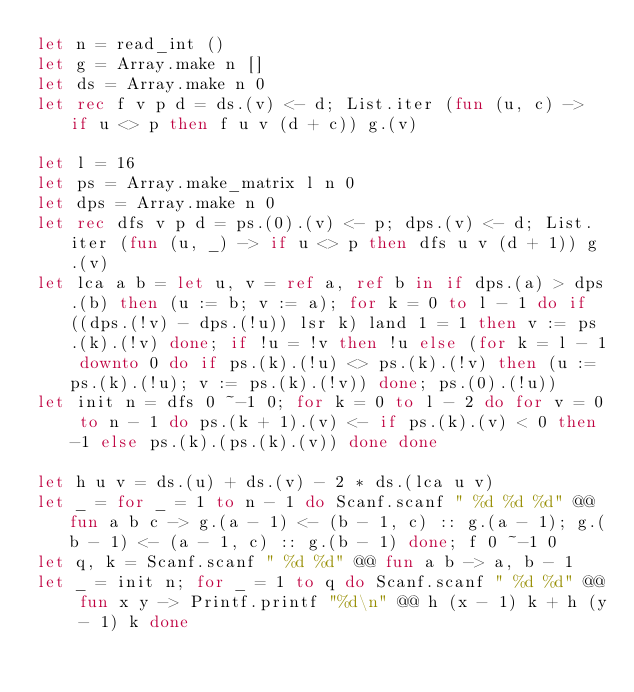Convert code to text. <code><loc_0><loc_0><loc_500><loc_500><_OCaml_>let n = read_int ()
let g = Array.make n []
let ds = Array.make n 0
let rec f v p d = ds.(v) <- d; List.iter (fun (u, c) -> if u <> p then f u v (d + c)) g.(v)

let l = 16
let ps = Array.make_matrix l n 0
let dps = Array.make n 0
let rec dfs v p d = ps.(0).(v) <- p; dps.(v) <- d; List.iter (fun (u, _) -> if u <> p then dfs u v (d + 1)) g.(v)
let lca a b = let u, v = ref a, ref b in if dps.(a) > dps.(b) then (u := b; v := a); for k = 0 to l - 1 do if ((dps.(!v) - dps.(!u)) lsr k) land 1 = 1 then v := ps.(k).(!v) done; if !u = !v then !u else (for k = l - 1 downto 0 do if ps.(k).(!u) <> ps.(k).(!v) then (u := ps.(k).(!u); v := ps.(k).(!v)) done; ps.(0).(!u))
let init n = dfs 0 ~-1 0; for k = 0 to l - 2 do for v = 0 to n - 1 do ps.(k + 1).(v) <- if ps.(k).(v) < 0 then -1 else ps.(k).(ps.(k).(v)) done done

let h u v = ds.(u) + ds.(v) - 2 * ds.(lca u v)
let _ = for _ = 1 to n - 1 do Scanf.scanf " %d %d %d" @@ fun a b c -> g.(a - 1) <- (b - 1, c) :: g.(a - 1); g.(b - 1) <- (a - 1, c) :: g.(b - 1) done; f 0 ~-1 0
let q, k = Scanf.scanf " %d %d" @@ fun a b -> a, b - 1
let _ = init n; for _ = 1 to q do Scanf.scanf " %d %d" @@ fun x y -> Printf.printf "%d\n" @@ h (x - 1) k + h (y - 1) k done</code> 